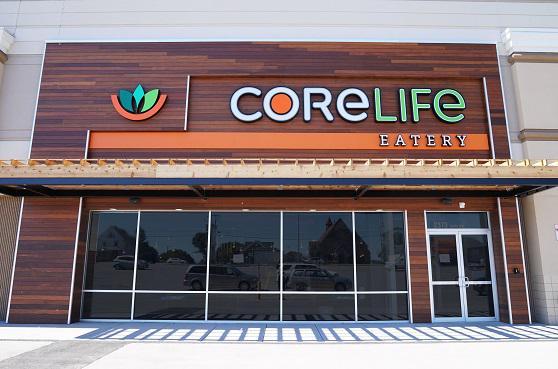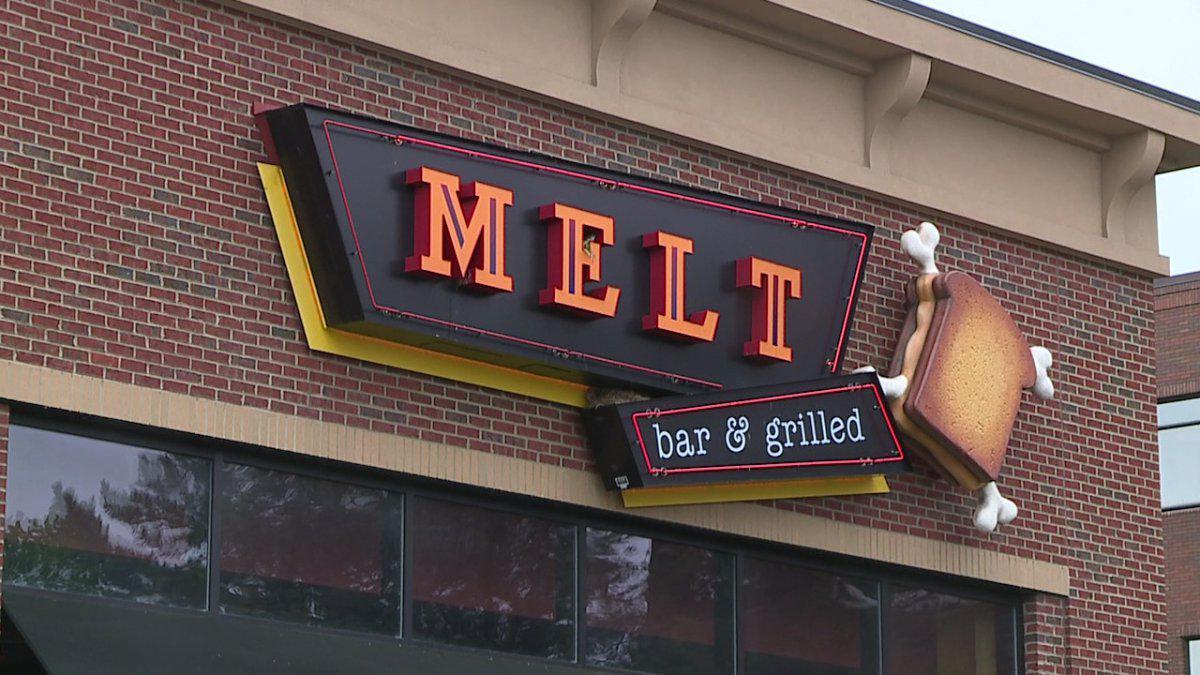The first image is the image on the left, the second image is the image on the right. For the images displayed, is the sentence "A white and orange banner is hanging on the front of a restaurant." factually correct? Answer yes or no. No. The first image is the image on the left, the second image is the image on the right. Considering the images on both sides, is "Two restaurants are displaying a permanent sign with the name Core Life Eatery." valid? Answer yes or no. No. 